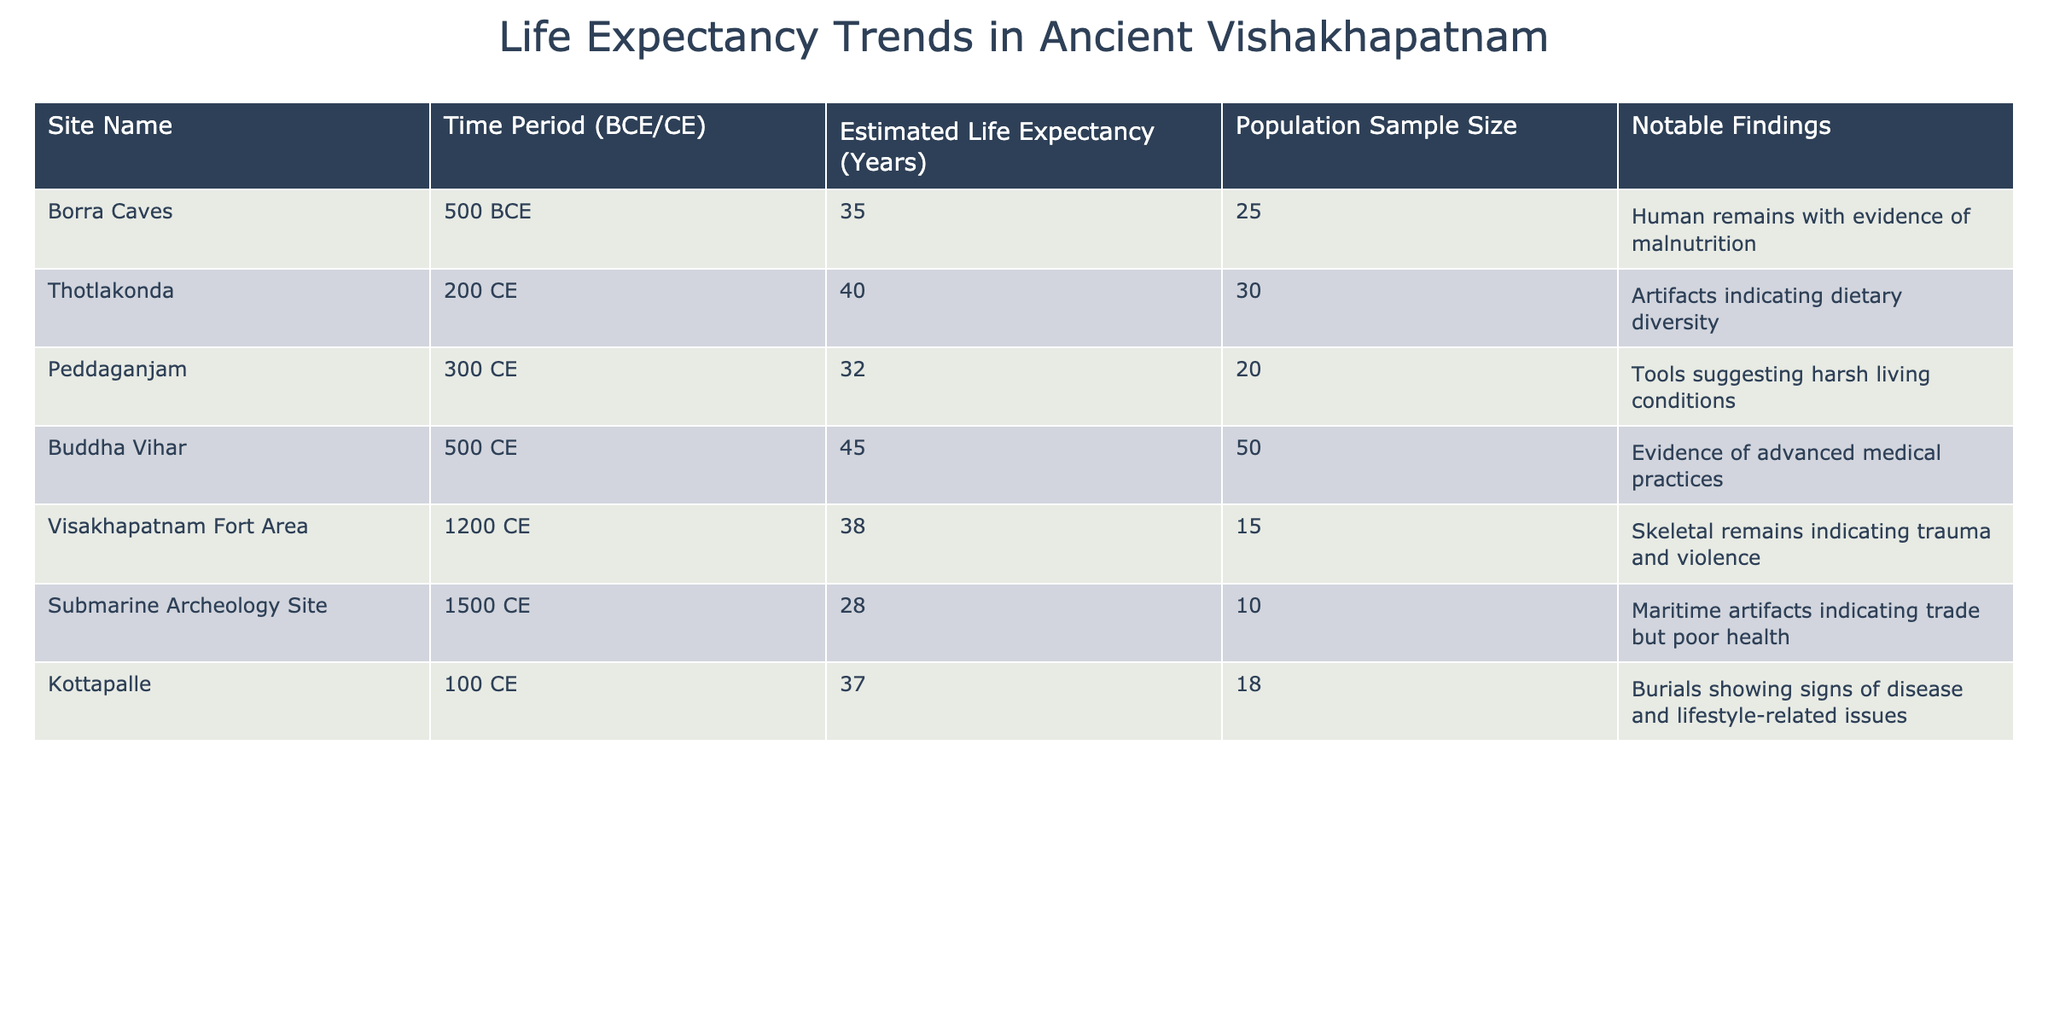What is the estimated life expectancy at Borra Caves? The table shows that Borra Caves has an estimated life expectancy of 35 years as per the provided data.
Answer: 35 Which site had the highest estimated life expectancy? By scanning the "Estimated Life Expectancy" column, Buddha Vihar stands out with 45 years, which is higher than all other sites listed.
Answer: 45 How many sites had an estimated life expectancy of less than 35 years? Looking at the table, we find two sites: Peddaganjam with 32 years and Submarine Archeology Site with 28 years, confirming that the total number of such sites is two.
Answer: 2 What is the average life expectancy across all the sites listed? To find the average, first add the estimated life expectancies: 35 + 40 + 32 + 45 + 38 + 28 + 37 = 315. There are 7 sites, so the average is calculated as 315 / 7 = 45.
Answer: 45 Is the life expectancy at Thotlakonda greater than that at Kottapalle? Comparing the values, Thotlakonda's estimated life expectancy is 40 years while Kottapalle's is 37 years, confirming that Thotlakonda is indeed greater.
Answer: Yes What was the population sample size at the Submarine Archeology Site and how does it compare to that at Buddha Vihar? The population sample size at the Submarine Archeology Site is 10, while at Buddha Vihar it is 50. This indicates that Buddha Vihar had a significantly larger sample size.
Answer: 10; Larger in Buddha Vihar For how many sites the notable findings relate to health issues? Analyzing the "Notable Findings" column, both Borra Caves and Submarine Archeology Site indicate health issues, thus it can be counted that there are two such sites.
Answer: 2 What is the difference in estimated life expectancy between the earliest and latest sites? The earliest site is Borra Caves with an expectancy of 35 years and the latest is the Submarine Archeology Site with 28 years. The difference is calculated as 35 - 28 = 7 years.
Answer: 7 What percentage of the sites had a life expectancy below 35 years? Out of 7 sites, 2 sites had less than 35 years. The percentage is (2/7) * 100 which equals approximately 28.57%.
Answer: 28.57% Which site had both a lower life expectancy and a smaller sample size compared to the average across all sites? The average life expectancy is 45 years. Both the Submarine Archeology Site (28 years, sample size of 10) and Peddaganjam (32 years, sample size of 20) have life expectancies below the average and also smaller sample sizes than the average sample size, leading to both being valid responses.
Answer: Submarine Archeology Site and Peddaganjam 